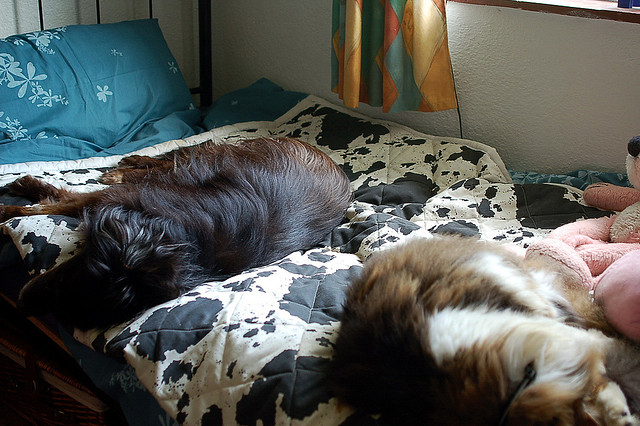What breed do the dogs seem to be? The two dogs in the photo look like they could be of the Spaniel breed, known for their wavy fur and floppy ears. They appear quite content as they rest, exemplifying the calm and sweet disposition that Spaniels are often cherished for. 